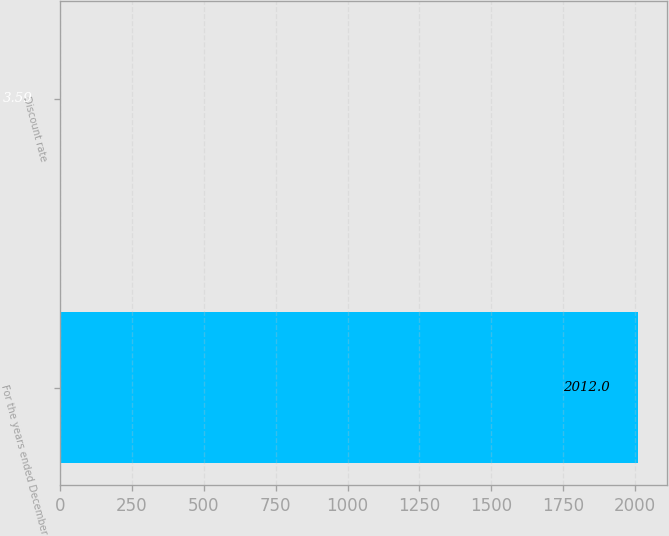<chart> <loc_0><loc_0><loc_500><loc_500><bar_chart><fcel>For the years ended December<fcel>Discount rate<nl><fcel>2012<fcel>3.59<nl></chart> 